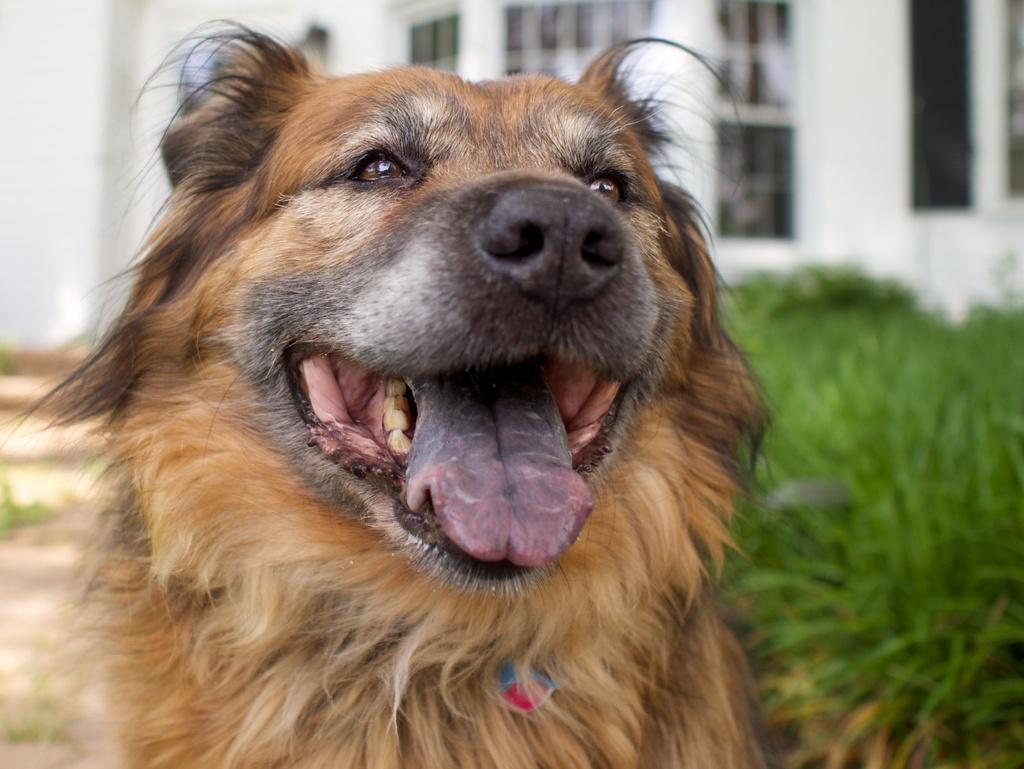Please provide a concise description of this image. In this image I can see the dog which is in brown and black color. To the side of the dog I can see the plants. In the back there is a building which is in white color. 